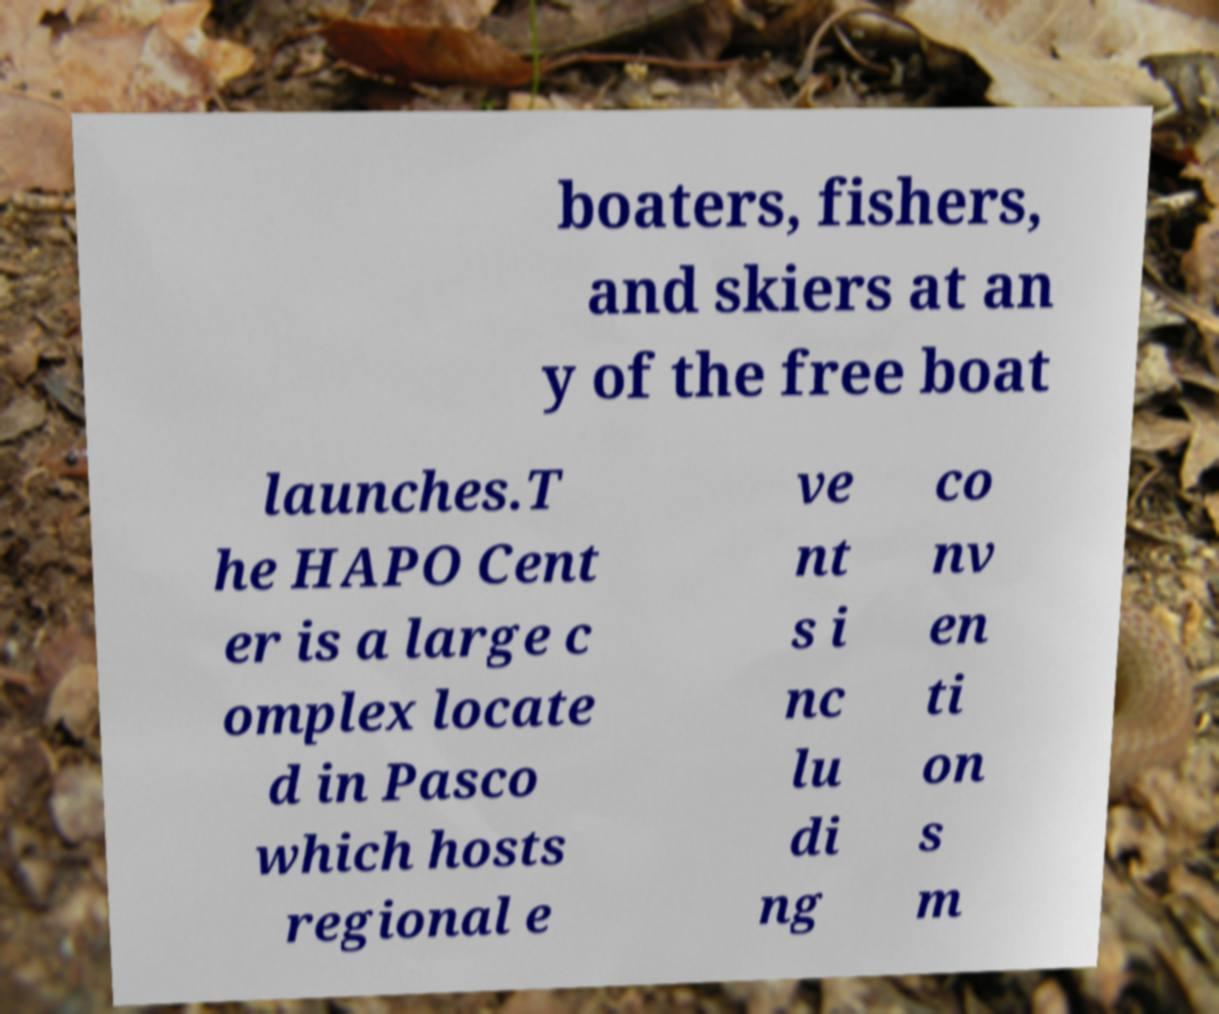Can you accurately transcribe the text from the provided image for me? boaters, fishers, and skiers at an y of the free boat launches.T he HAPO Cent er is a large c omplex locate d in Pasco which hosts regional e ve nt s i nc lu di ng co nv en ti on s m 